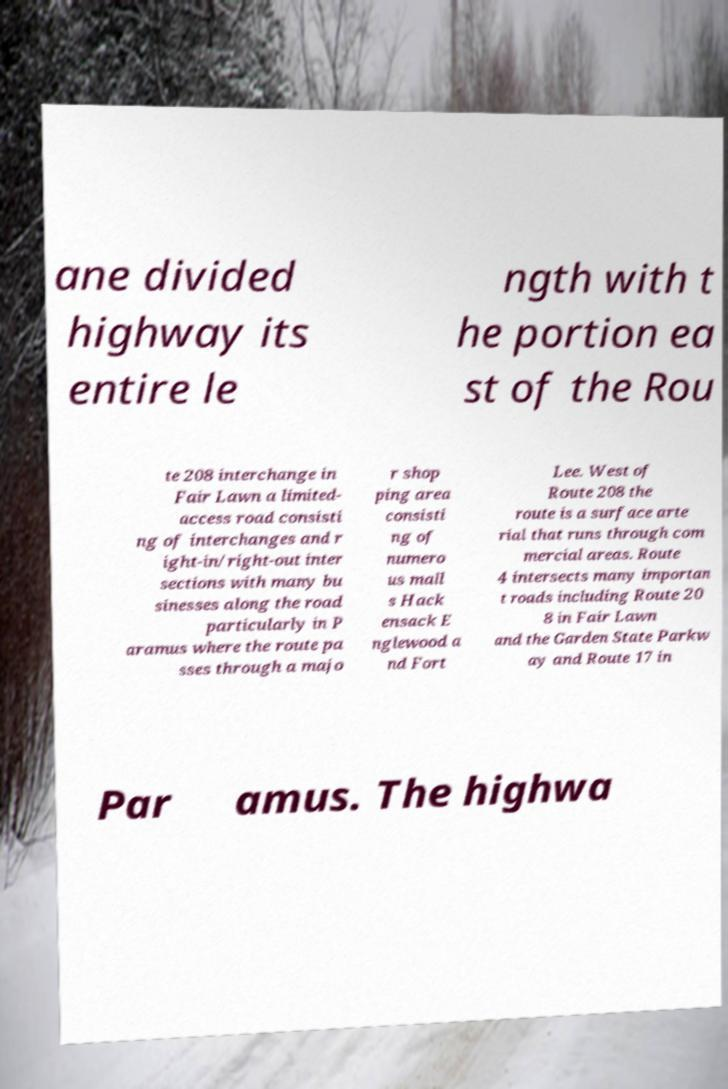There's text embedded in this image that I need extracted. Can you transcribe it verbatim? ane divided highway its entire le ngth with t he portion ea st of the Rou te 208 interchange in Fair Lawn a limited- access road consisti ng of interchanges and r ight-in/right-out inter sections with many bu sinesses along the road particularly in P aramus where the route pa sses through a majo r shop ping area consisti ng of numero us mall s Hack ensack E nglewood a nd Fort Lee. West of Route 208 the route is a surface arte rial that runs through com mercial areas. Route 4 intersects many importan t roads including Route 20 8 in Fair Lawn and the Garden State Parkw ay and Route 17 in Par amus. The highwa 